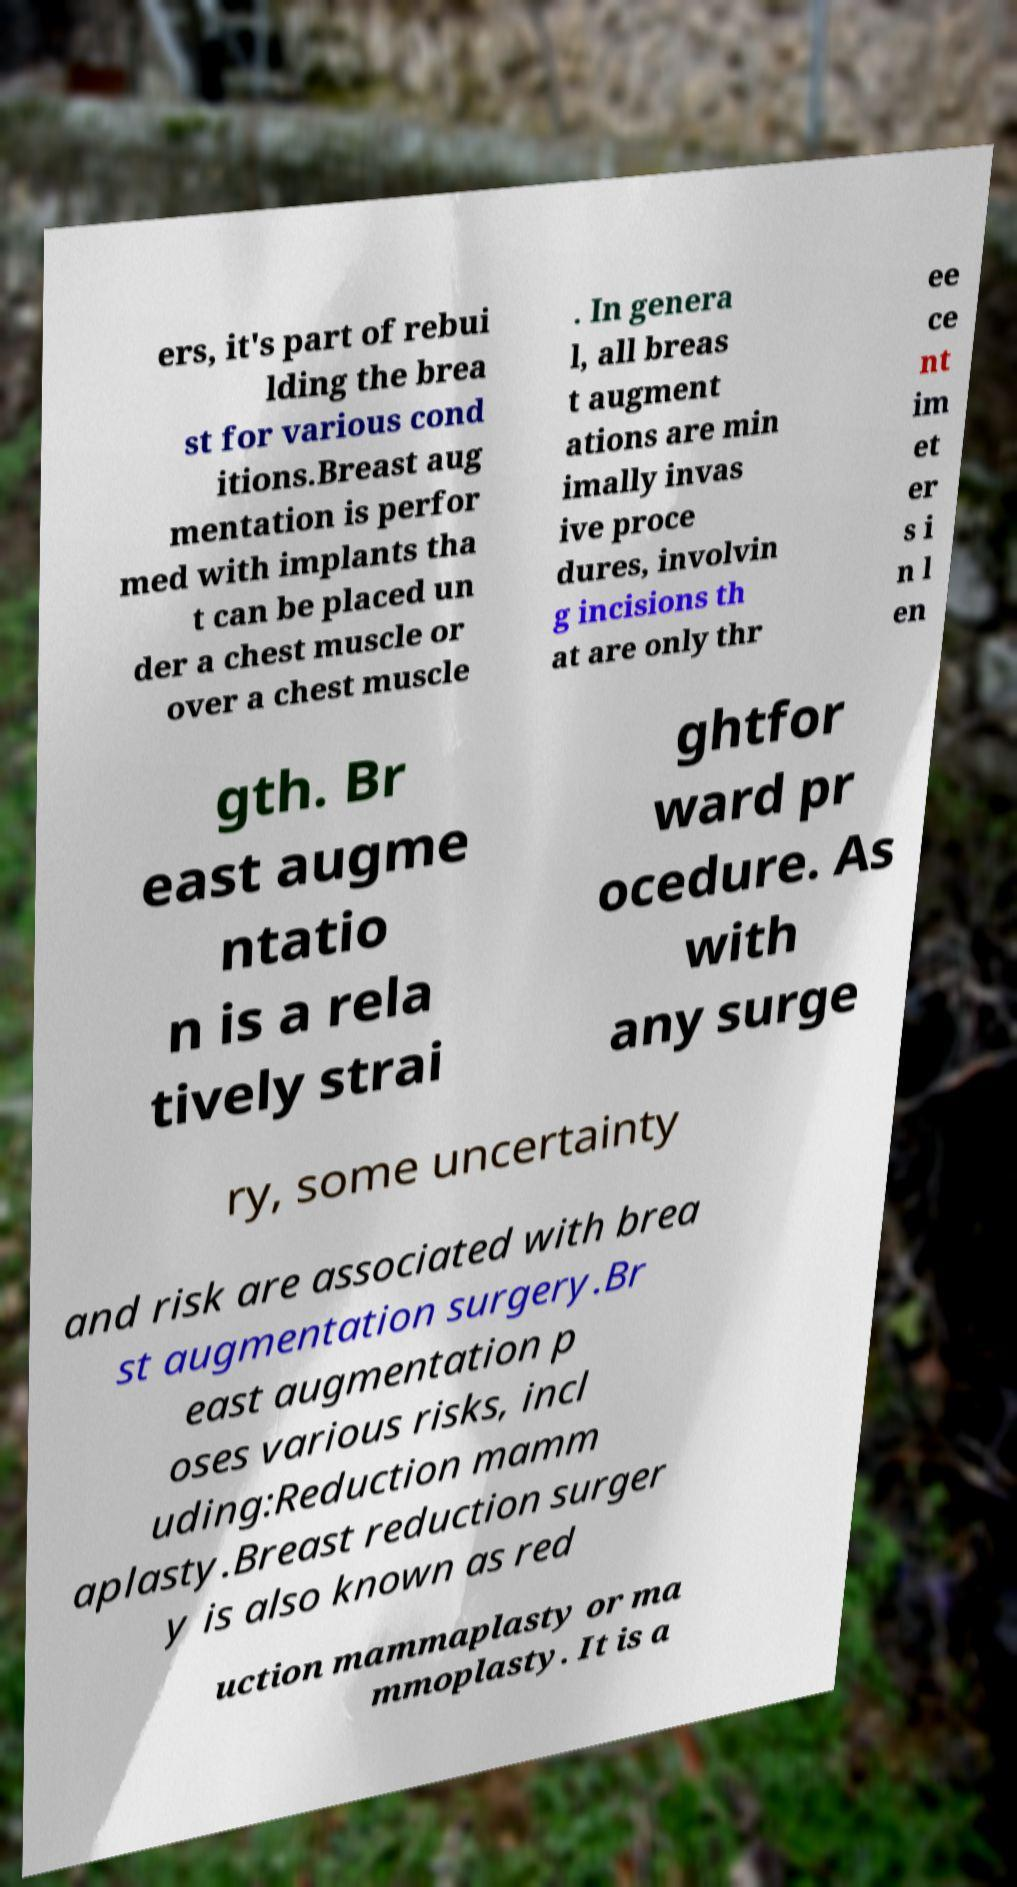There's text embedded in this image that I need extracted. Can you transcribe it verbatim? ers, it's part of rebui lding the brea st for various cond itions.Breast aug mentation is perfor med with implants tha t can be placed un der a chest muscle or over a chest muscle . In genera l, all breas t augment ations are min imally invas ive proce dures, involvin g incisions th at are only thr ee ce nt im et er s i n l en gth. Br east augme ntatio n is a rela tively strai ghtfor ward pr ocedure. As with any surge ry, some uncertainty and risk are associated with brea st augmentation surgery.Br east augmentation p oses various risks, incl uding:Reduction mamm aplasty.Breast reduction surger y is also known as red uction mammaplasty or ma mmoplasty. It is a 